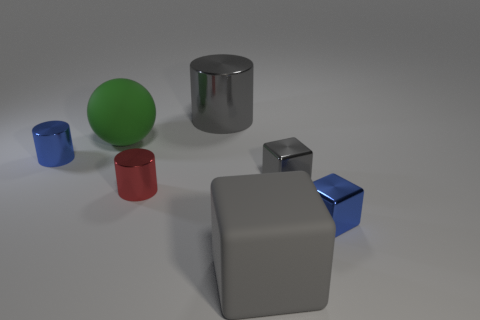There is a cylinder that is the same color as the large matte cube; what is its size?
Provide a short and direct response. Large. How many other objects are there of the same material as the red cylinder?
Keep it short and to the point. 4. Does the green rubber thing have the same shape as the big gray matte object?
Provide a short and direct response. No. What is the size of the gray thing in front of the tiny gray object?
Your answer should be compact. Large. Is the size of the blue shiny block the same as the gray metal object that is to the right of the big gray metallic cylinder?
Provide a succinct answer. Yes. Is the number of small red metal cylinders to the right of the big gray metal cylinder less than the number of tiny green spheres?
Your response must be concise. No. What material is the tiny blue thing that is the same shape as the red object?
Offer a terse response. Metal. What shape is the big object that is both right of the green rubber thing and behind the small red shiny object?
Provide a short and direct response. Cylinder. What shape is the tiny gray object that is the same material as the blue cube?
Give a very brief answer. Cube. What material is the cylinder behind the blue cylinder?
Your response must be concise. Metal. 